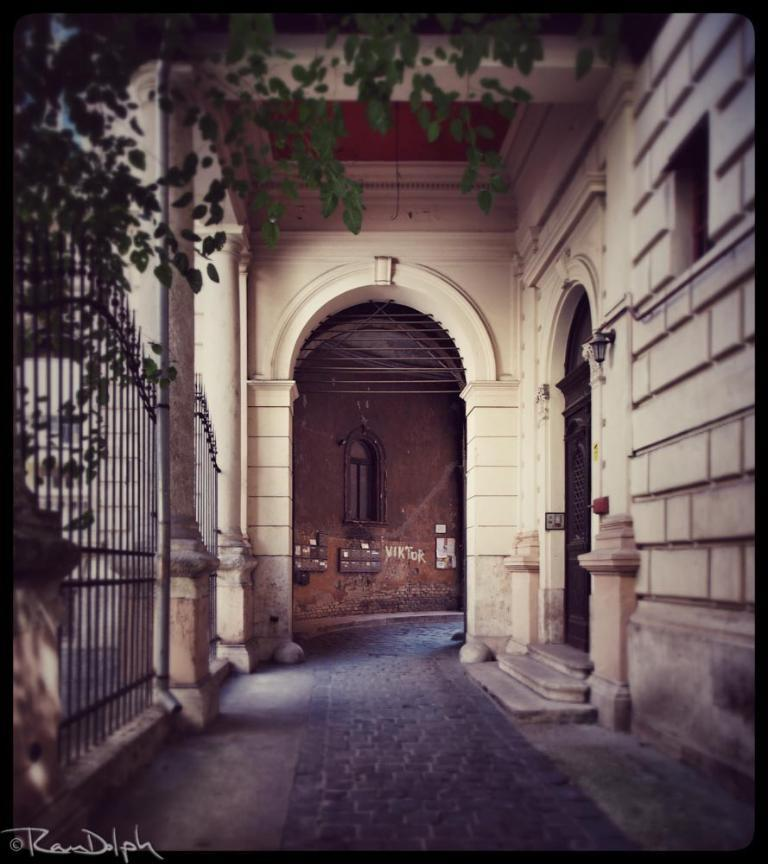What type of structure can be seen in the image? There is a wall in the image. Are there any openings in the wall? Yes, there is a door and a window in the image. What is located near the wall? There is a fence in the image. What natural element is present in the image? There is a tree in the image. Is there any indication of the image's origin or ownership? Yes, there is a watermark in the image. What song is being sung by the sister in the image? There is no sister or song present in the image. What type of plastic material can be seen in the image? There is no plastic material present in the image. 